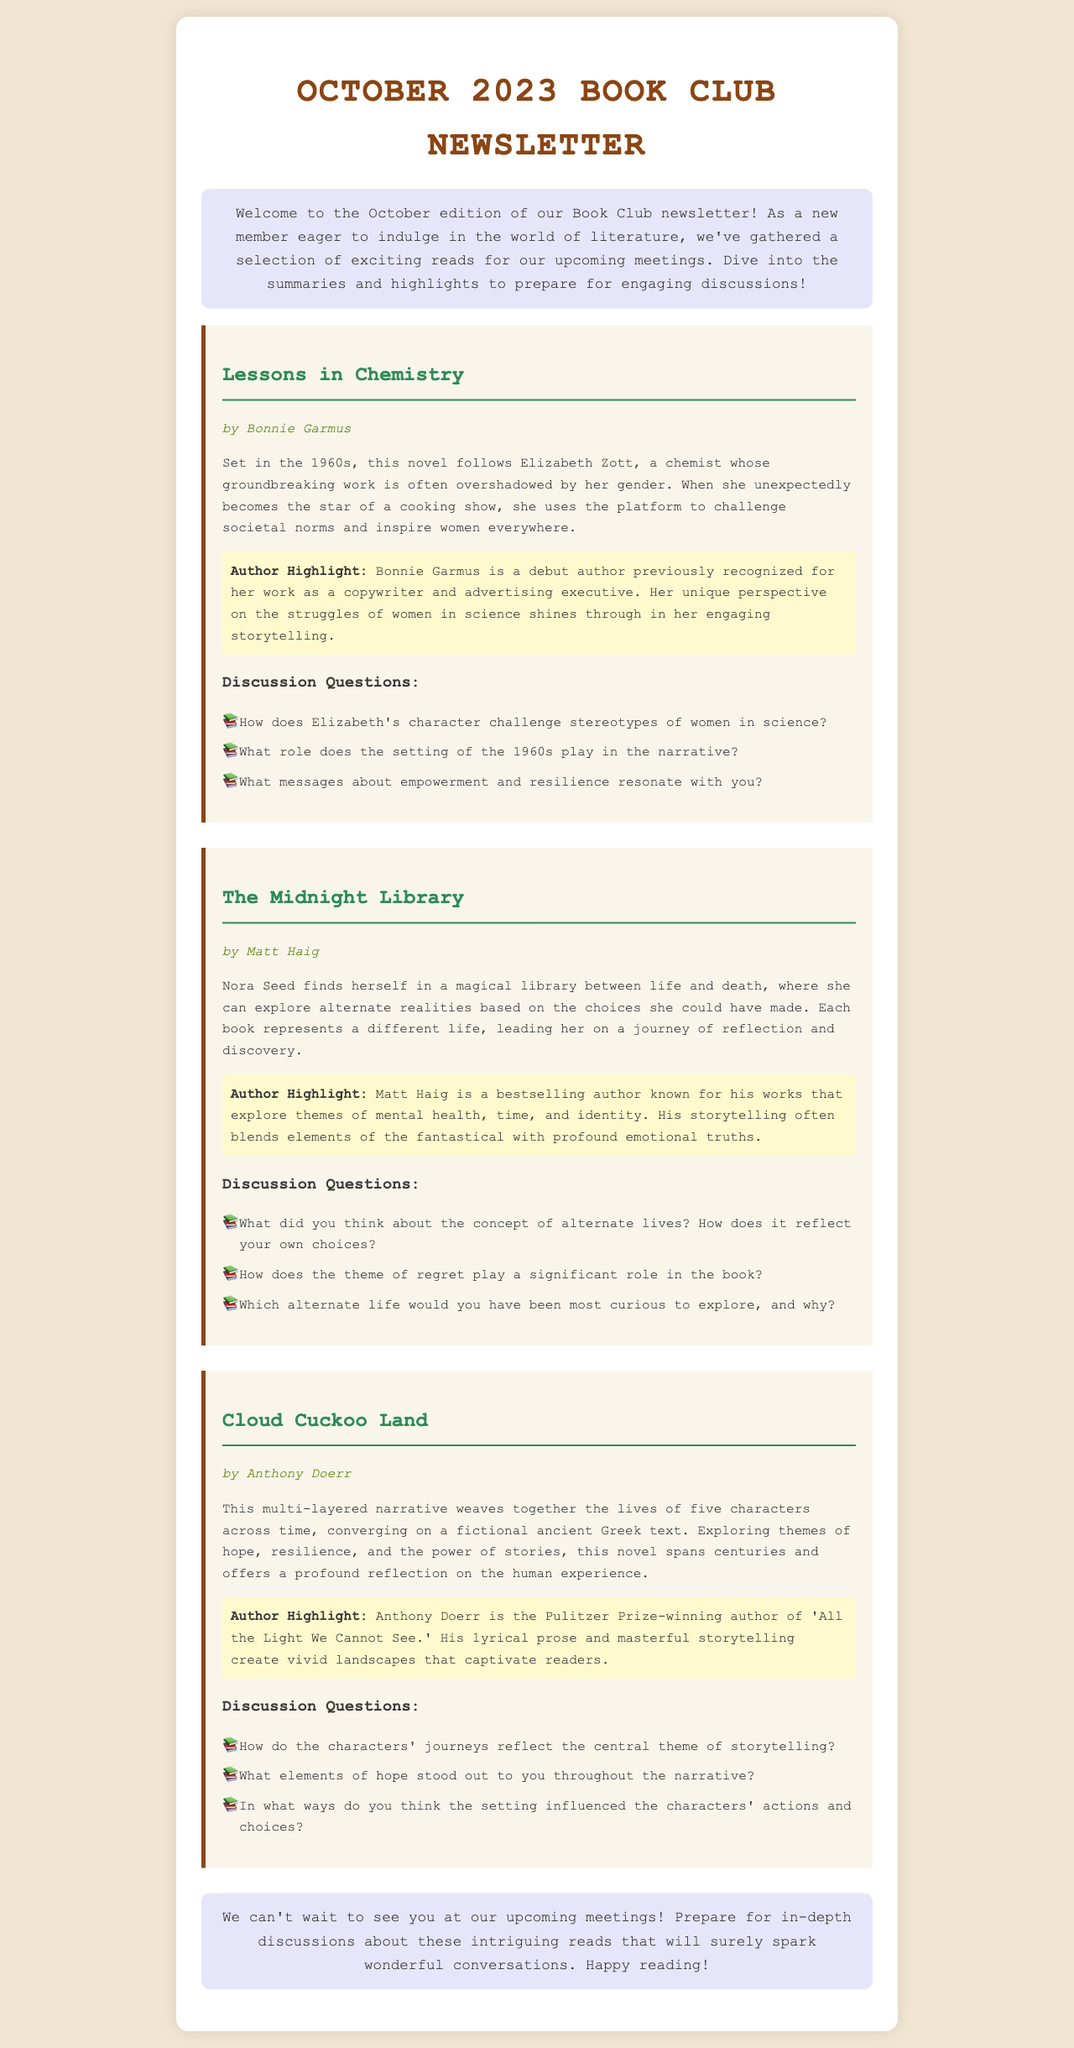What is the title of the first book featured? The first book listed in the newsletter is identified by the title, "Lessons in Chemistry."
Answer: Lessons in Chemistry Who is the author of "The Midnight Library"? The author of "The Midnight Library" is mentioned in the document as Matt Haig.
Answer: Matt Haig What decade is the setting of "Lessons in Chemistry"? The setting of "Lessons in Chemistry" is specified as the 1960s.
Answer: 1960s What genre does "Cloud Cuckoo Land" explore? The document indicates that "Cloud Cuckoo Land" deals with themes of hope, resilience, and the power of stories, implying its literary genre.
Answer: Literary How many discussion questions are provided for each book? The document displays three discussion questions for each of the featured books.
Answer: Three What is a significant theme of "The Midnight Library"? The newsletter highlights the theme of regret as a significant aspect in "The Midnight Library."
Answer: Regret What is the name of the author highlighted for "Cloud Cuckoo Land"? The author highlighted for "Cloud Cuckoo Land" is Anthony Doerr.
Answer: Anthony Doerr What narrative perspectives are explored in "Cloud Cuckoo Land"? The document states that the narrative weaves together the lives of five characters across time, indicating multiple perspectives.
Answer: Five characters What should members prepare for regarding the upcoming meetings? The document advises members to prepare for in-depth discussions about the books selected for the meetings.
Answer: In-depth discussions 